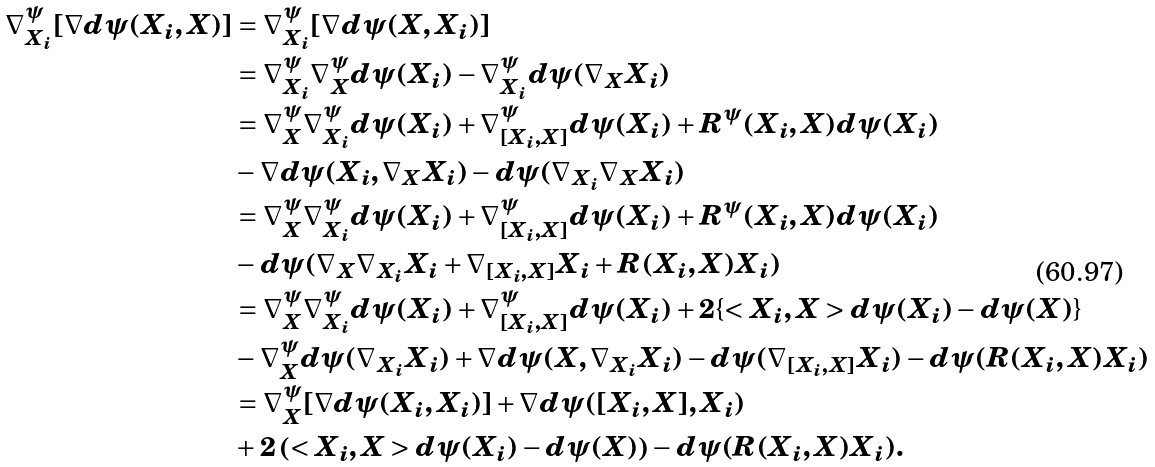Convert formula to latex. <formula><loc_0><loc_0><loc_500><loc_500>\nabla _ { X _ { i } } ^ { \psi } [ \nabla d \psi ( X _ { i } , X ) ] & = \nabla _ { X _ { i } } ^ { \psi } [ \nabla d \psi ( X , X _ { i } ) ] \\ & = \nabla _ { X _ { i } } ^ { \psi } \nabla _ { X } ^ { \psi } d \psi ( X _ { i } ) - \nabla _ { X _ { i } } ^ { \psi } d \psi ( \nabla _ { X } X _ { i } ) \\ & = \nabla _ { X } ^ { \psi } \nabla _ { X _ { i } } ^ { \psi } d \psi ( X _ { i } ) + \nabla _ { [ X _ { i } , X ] } ^ { \psi } d \psi ( X _ { i } ) + R ^ { \psi } ( X _ { i } , X ) d \psi ( X _ { i } ) \\ & - \nabla d \psi ( X _ { i } , \nabla _ { X } X _ { i } ) - d \psi ( \nabla _ { X _ { i } } \nabla _ { X } X _ { i } ) \\ & = \nabla _ { X } ^ { \psi } \nabla _ { X _ { i } } ^ { \psi } d \psi ( X _ { i } ) + \nabla _ { [ X _ { i } , X ] } ^ { \psi } d \psi ( X _ { i } ) + R ^ { \psi } ( X _ { i } , X ) d \psi ( X _ { i } ) \\ & - d \psi ( \nabla _ { X } \nabla _ { X _ { i } } X _ { i } + \nabla _ { [ X _ { i } , X ] } X _ { i } + R ( X _ { i } , X ) X _ { i } ) \\ & = \nabla _ { X } ^ { \psi } \nabla _ { X _ { i } } ^ { \psi } d \psi ( X _ { i } ) + \nabla _ { [ X _ { i } , X ] } ^ { \psi } d \psi ( X _ { i } ) + 2 \{ < X _ { i } , X > d \psi ( X _ { i } ) - d \psi ( X ) \} \\ & - \nabla _ { X } ^ { \psi } d \psi ( \nabla _ { X _ { i } } X _ { i } ) + \nabla d \psi ( X , \nabla _ { X _ { i } } X _ { i } ) - d \psi ( \nabla _ { [ X _ { i } , X ] } X _ { i } ) - d \psi ( R ( X _ { i } , X ) X _ { i } ) \\ & = \nabla _ { X } ^ { \psi } [ \nabla d \psi ( X _ { i } , X _ { i } ) ] + \nabla d \psi ( [ X _ { i } , X ] , X _ { i } ) \\ & + 2 \left ( < X _ { i } , X > d \psi ( X _ { i } ) - d \psi ( X ) \right ) - d \psi ( R ( X _ { i } , X ) X _ { i } ) .</formula> 